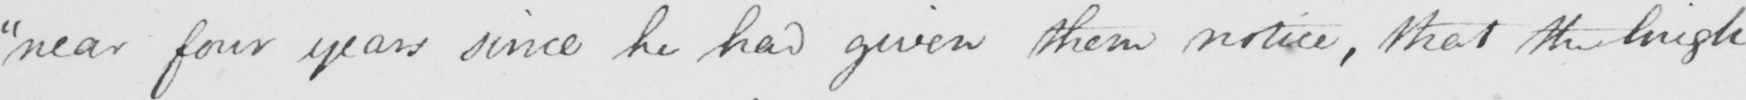Please provide the text content of this handwritten line. " near four years since he had given them notice , that the high 